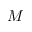<formula> <loc_0><loc_0><loc_500><loc_500>M</formula> 